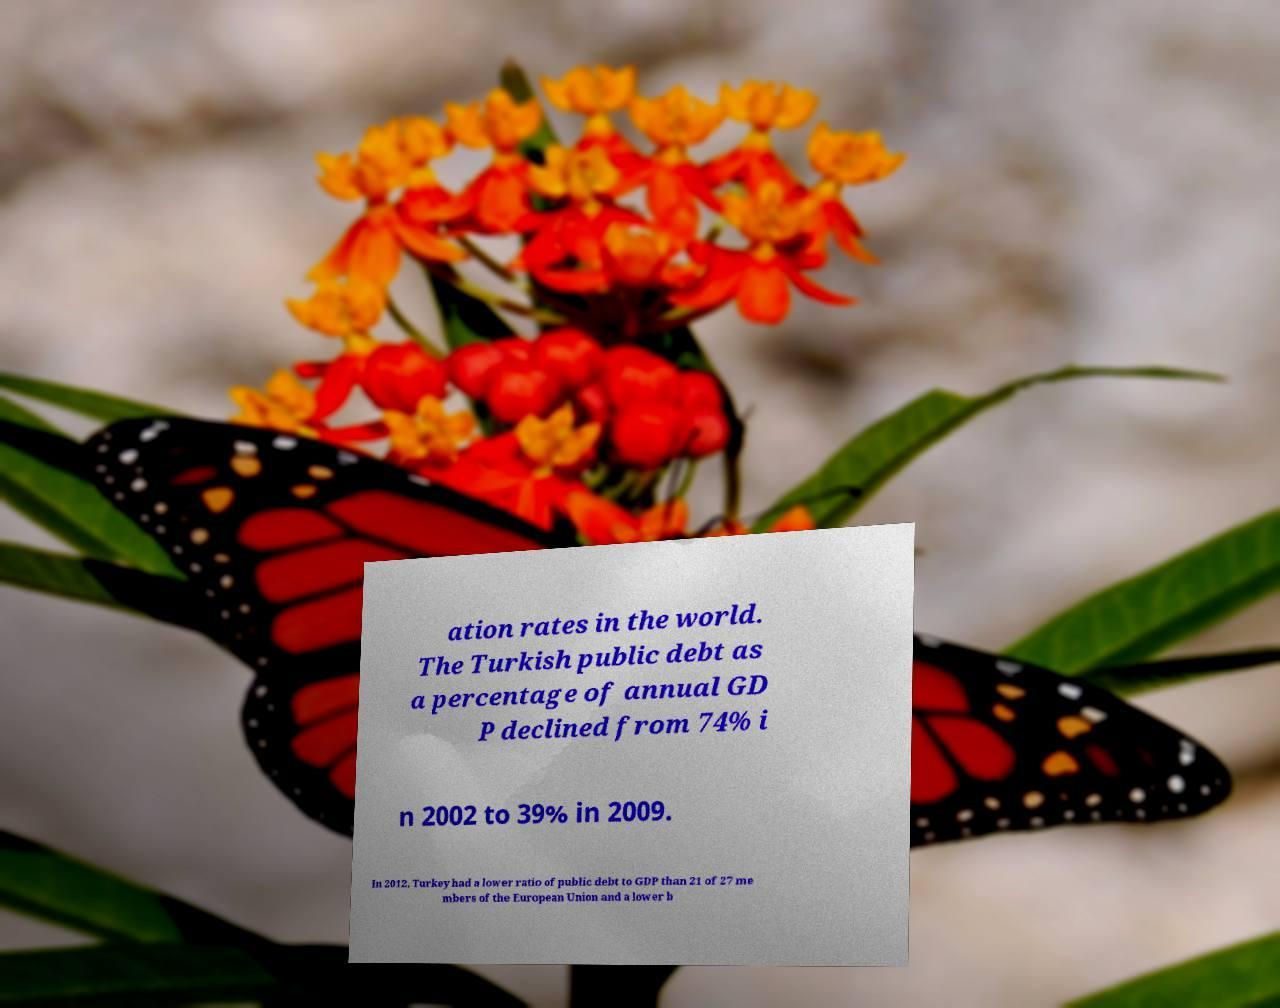Could you extract and type out the text from this image? ation rates in the world. The Turkish public debt as a percentage of annual GD P declined from 74% i n 2002 to 39% in 2009. In 2012, Turkey had a lower ratio of public debt to GDP than 21 of 27 me mbers of the European Union and a lower b 